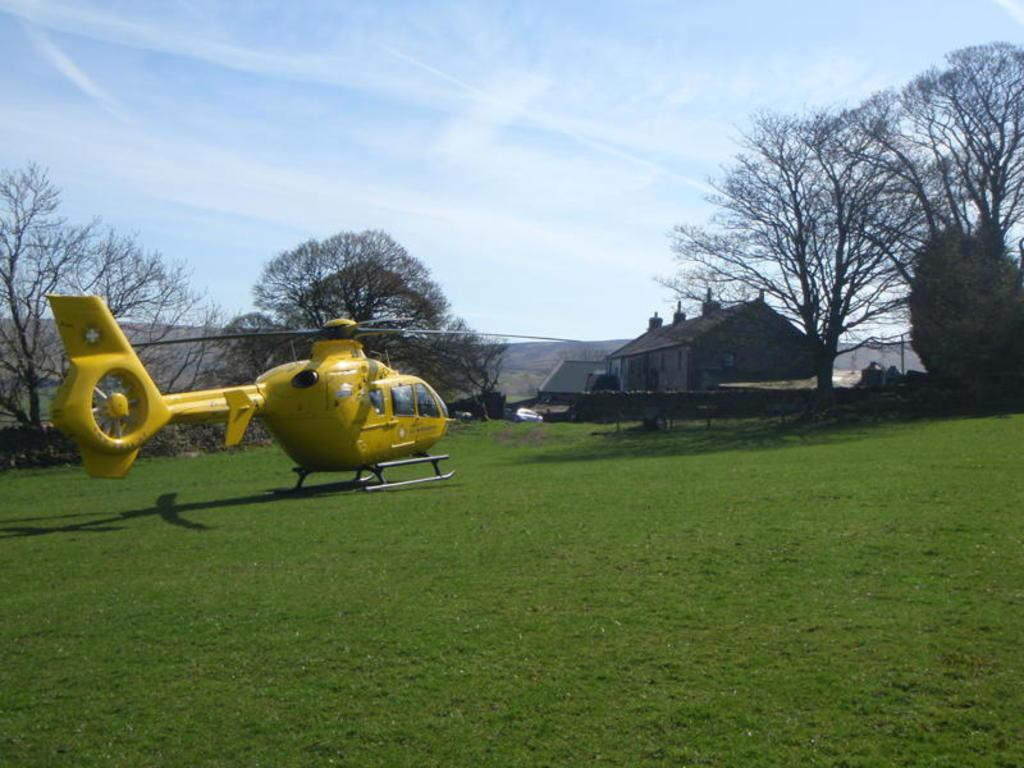What is the main subject of the image? The main subject of the image is a helicopter. Where is the helicopter located in the image? The helicopter is on the ground in the image. What can be seen in the background of the image? There are trees and houses in the background of the image. What is visible at the top of the image? The sky is clear and visible at the top of the image. Can you see a rabbit playing with a zipper near the helicopter in the image? No, there is no rabbit or zipper present in the image. The image only features a helicopter on the ground, trees and houses in the background, and a clear sky visible at the top. 